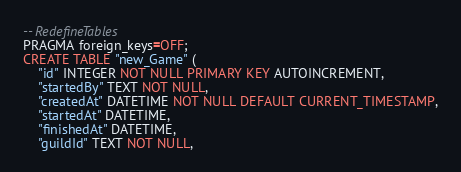Convert code to text. <code><loc_0><loc_0><loc_500><loc_500><_SQL_>-- RedefineTables
PRAGMA foreign_keys=OFF;
CREATE TABLE "new_Game" (
    "id" INTEGER NOT NULL PRIMARY KEY AUTOINCREMENT,
    "startedBy" TEXT NOT NULL,
    "createdAt" DATETIME NOT NULL DEFAULT CURRENT_TIMESTAMP,
    "startedAt" DATETIME,
    "finishedAt" DATETIME,
    "guildId" TEXT NOT NULL,</code> 